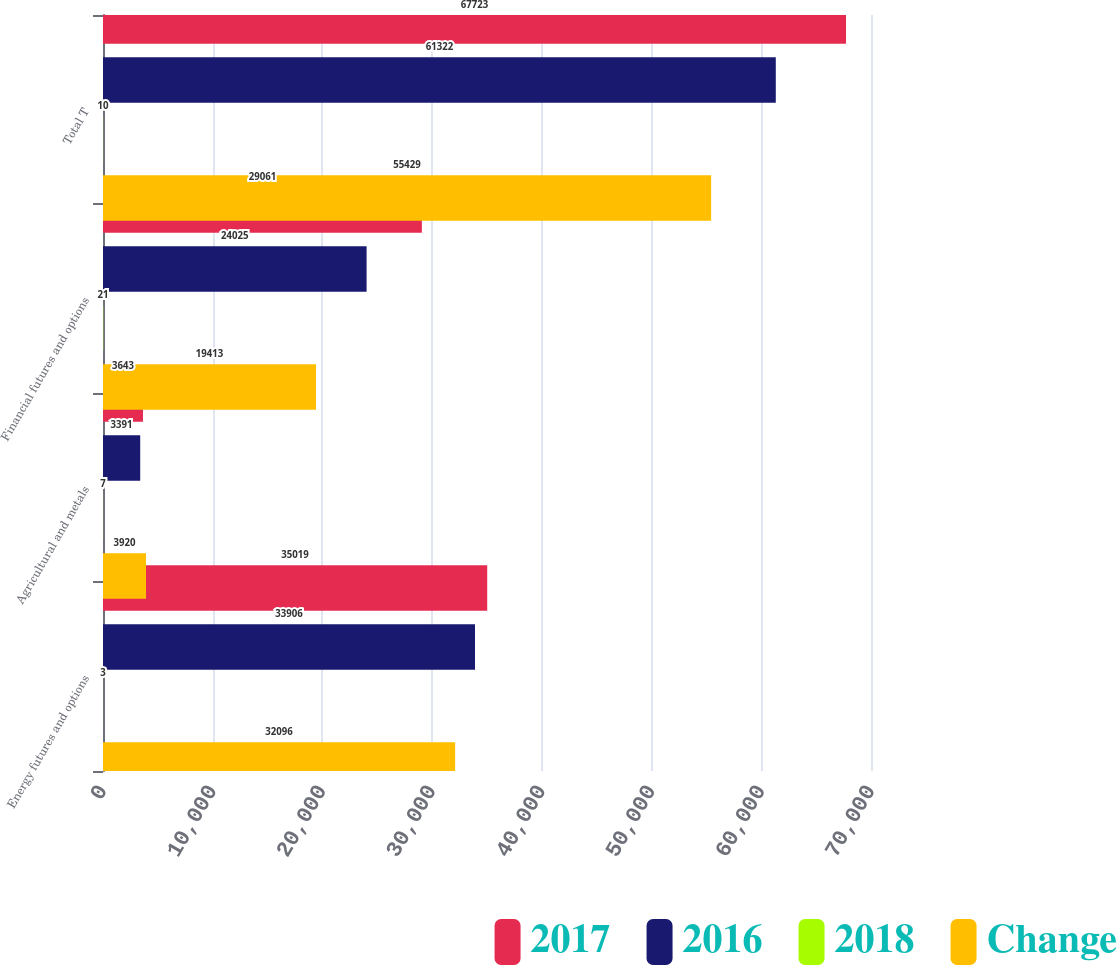<chart> <loc_0><loc_0><loc_500><loc_500><stacked_bar_chart><ecel><fcel>Energy futures and options<fcel>Agricultural and metals<fcel>Financial futures and options<fcel>Total T<nl><fcel>2017<fcel>35019<fcel>3643<fcel>29061<fcel>67723<nl><fcel>2016<fcel>33906<fcel>3391<fcel>24025<fcel>61322<nl><fcel>2018<fcel>3<fcel>7<fcel>21<fcel>10<nl><fcel>Change<fcel>32096<fcel>3920<fcel>19413<fcel>55429<nl></chart> 